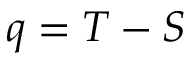<formula> <loc_0><loc_0><loc_500><loc_500>q = T - S</formula> 